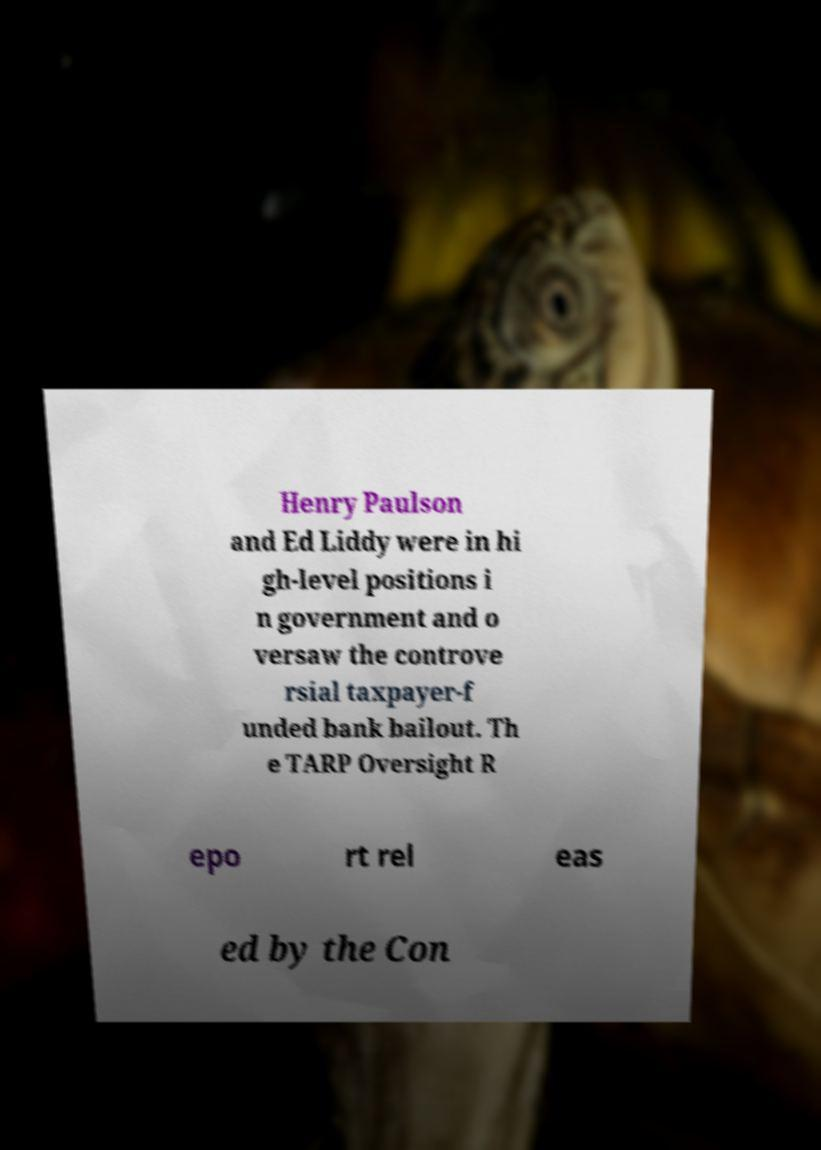For documentation purposes, I need the text within this image transcribed. Could you provide that? Henry Paulson and Ed Liddy were in hi gh-level positions i n government and o versaw the controve rsial taxpayer-f unded bank bailout. Th e TARP Oversight R epo rt rel eas ed by the Con 